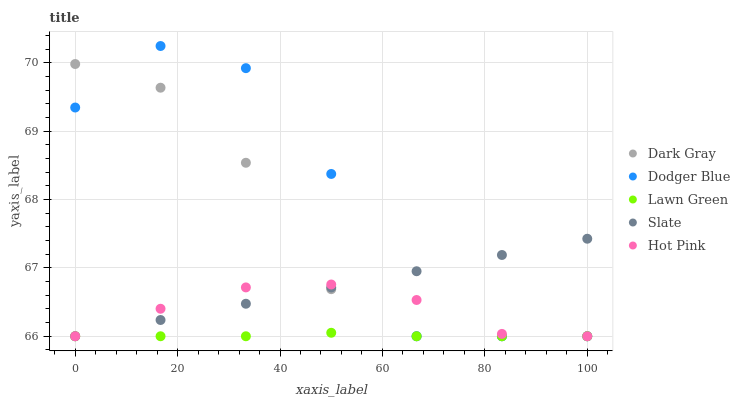Does Lawn Green have the minimum area under the curve?
Answer yes or no. Yes. Does Dodger Blue have the maximum area under the curve?
Answer yes or no. Yes. Does Slate have the minimum area under the curve?
Answer yes or no. No. Does Slate have the maximum area under the curve?
Answer yes or no. No. Is Slate the smoothest?
Answer yes or no. Yes. Is Dodger Blue the roughest?
Answer yes or no. Yes. Is Lawn Green the smoothest?
Answer yes or no. No. Is Lawn Green the roughest?
Answer yes or no. No. Does Dark Gray have the lowest value?
Answer yes or no. Yes. Does Dodger Blue have the highest value?
Answer yes or no. Yes. Does Slate have the highest value?
Answer yes or no. No. Does Dodger Blue intersect Dark Gray?
Answer yes or no. Yes. Is Dodger Blue less than Dark Gray?
Answer yes or no. No. Is Dodger Blue greater than Dark Gray?
Answer yes or no. No. 